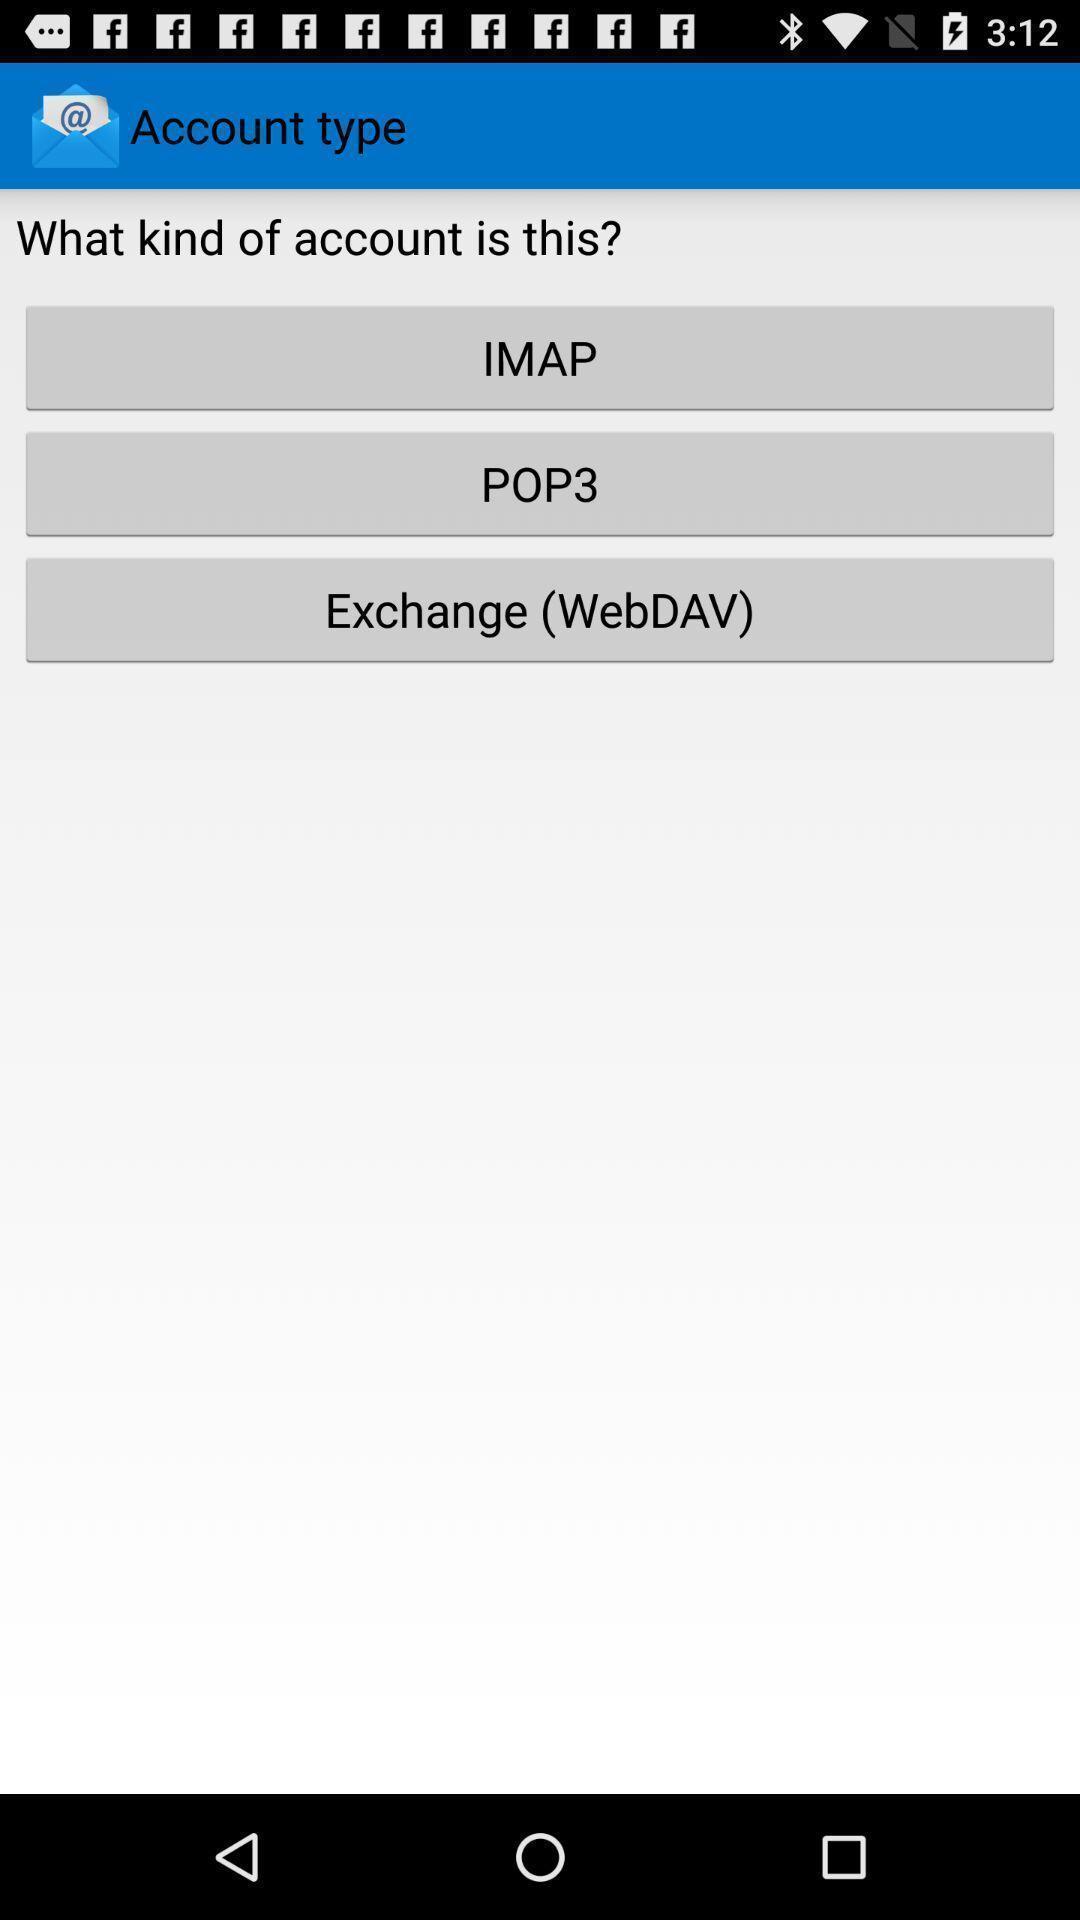Explain what's happening in this screen capture. Screen displaying multiple account type options. 